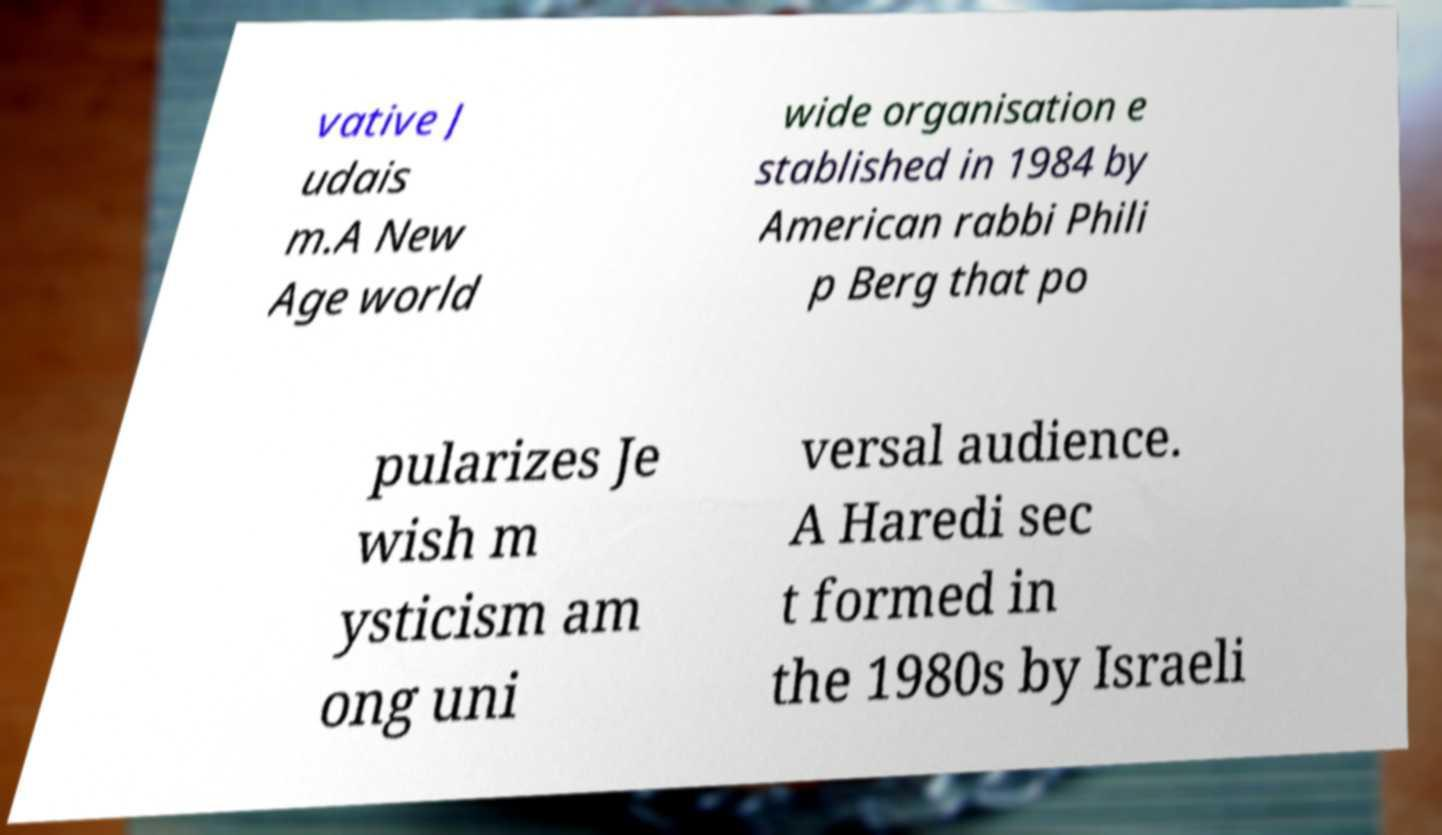I need the written content from this picture converted into text. Can you do that? vative J udais m.A New Age world wide organisation e stablished in 1984 by American rabbi Phili p Berg that po pularizes Je wish m ysticism am ong uni versal audience. A Haredi sec t formed in the 1980s by Israeli 